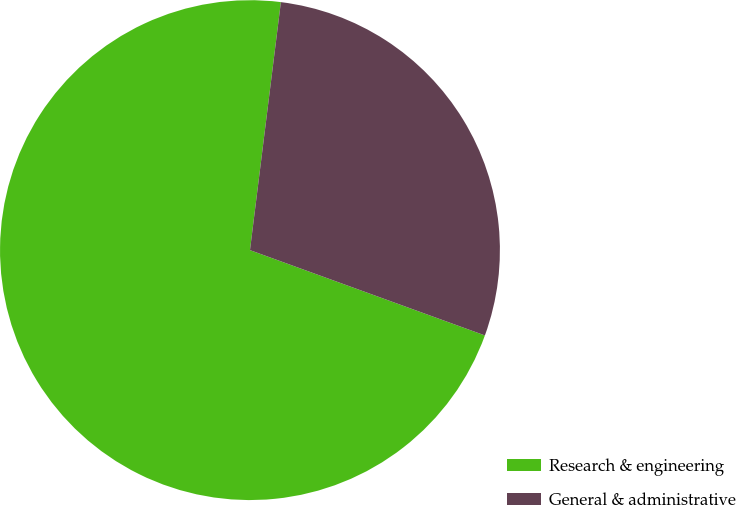Convert chart. <chart><loc_0><loc_0><loc_500><loc_500><pie_chart><fcel>Research & engineering<fcel>General & administrative<nl><fcel>71.43%<fcel>28.57%<nl></chart> 